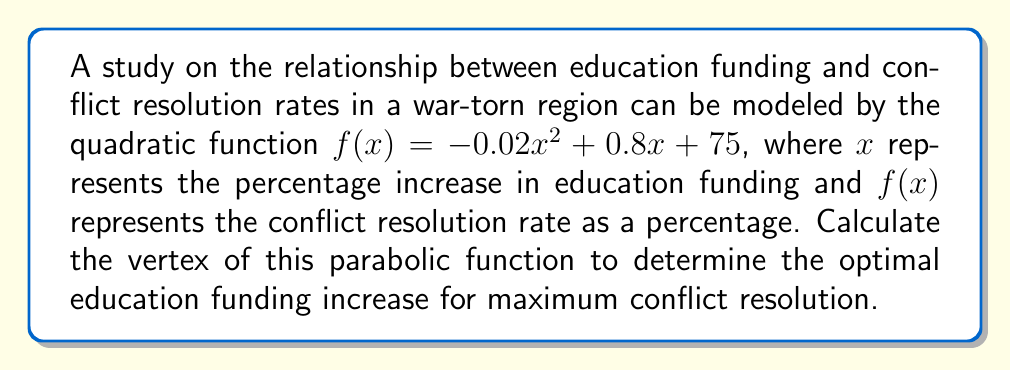Can you solve this math problem? To find the vertex of a parabolic function in the form $f(x) = ax^2 + bx + c$, we use the formula:

$x = -\frac{b}{2a}$

For our function $f(x) = -0.02x^2 + 0.8x + 75$:
$a = -0.02$
$b = 0.8$

Step 1: Calculate x-coordinate of the vertex
$$x = -\frac{0.8}{2(-0.02)} = -\frac{0.8}{-0.04} = 20$$

Step 2: Calculate y-coordinate of the vertex by plugging x into the original function
$$\begin{align}
f(20) &= -0.02(20)^2 + 0.8(20) + 75 \\
&= -0.02(400) + 16 + 75 \\
&= -8 + 16 + 75 \\
&= 83
\end{align}$$

Therefore, the vertex of the parabola is (20, 83).
Answer: (20, 83) 